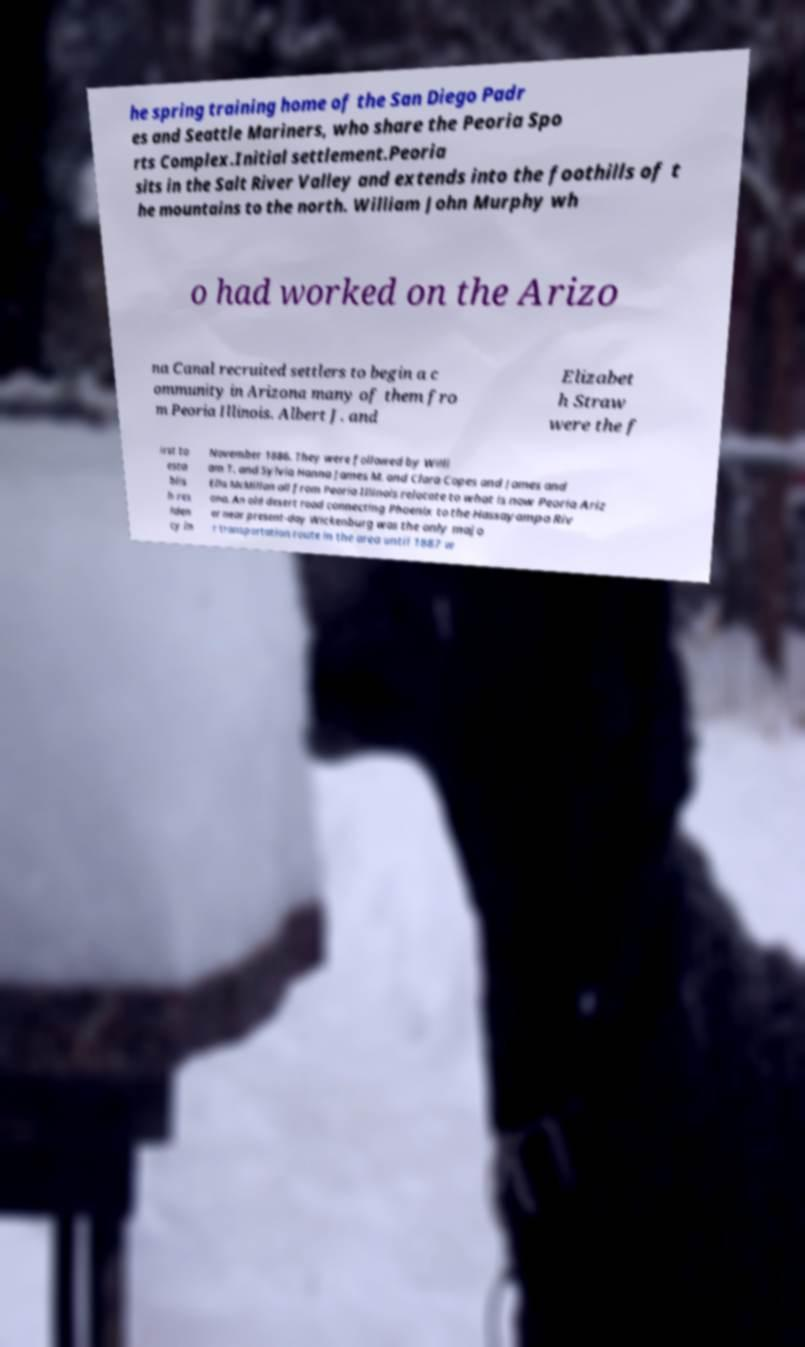Please identify and transcribe the text found in this image. he spring training home of the San Diego Padr es and Seattle Mariners, who share the Peoria Spo rts Complex.Initial settlement.Peoria sits in the Salt River Valley and extends into the foothills of t he mountains to the north. William John Murphy wh o had worked on the Arizo na Canal recruited settlers to begin a c ommunity in Arizona many of them fro m Peoria Illinois. Albert J. and Elizabet h Straw were the f irst to esta blis h res iden cy in November 1886. They were followed by Willi am T. and Sylvia Hanna James M. and Clara Copes and James and Ella McMillan all from Peoria Illinois relocate to what is now Peoria Ariz ona. An old desert road connecting Phoenix to the Hassayampa Riv er near present-day Wickenburg was the only majo r transportation route in the area until 1887 w 